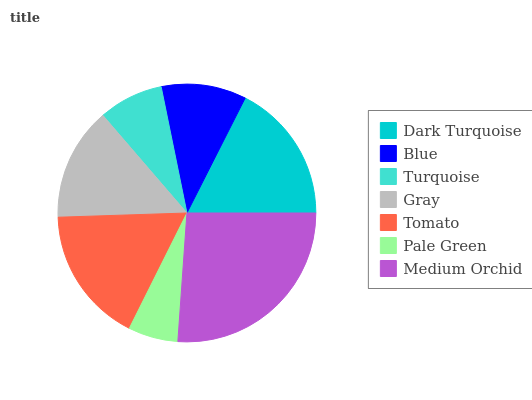Is Pale Green the minimum?
Answer yes or no. Yes. Is Medium Orchid the maximum?
Answer yes or no. Yes. Is Blue the minimum?
Answer yes or no. No. Is Blue the maximum?
Answer yes or no. No. Is Dark Turquoise greater than Blue?
Answer yes or no. Yes. Is Blue less than Dark Turquoise?
Answer yes or no. Yes. Is Blue greater than Dark Turquoise?
Answer yes or no. No. Is Dark Turquoise less than Blue?
Answer yes or no. No. Is Gray the high median?
Answer yes or no. Yes. Is Gray the low median?
Answer yes or no. Yes. Is Blue the high median?
Answer yes or no. No. Is Dark Turquoise the low median?
Answer yes or no. No. 